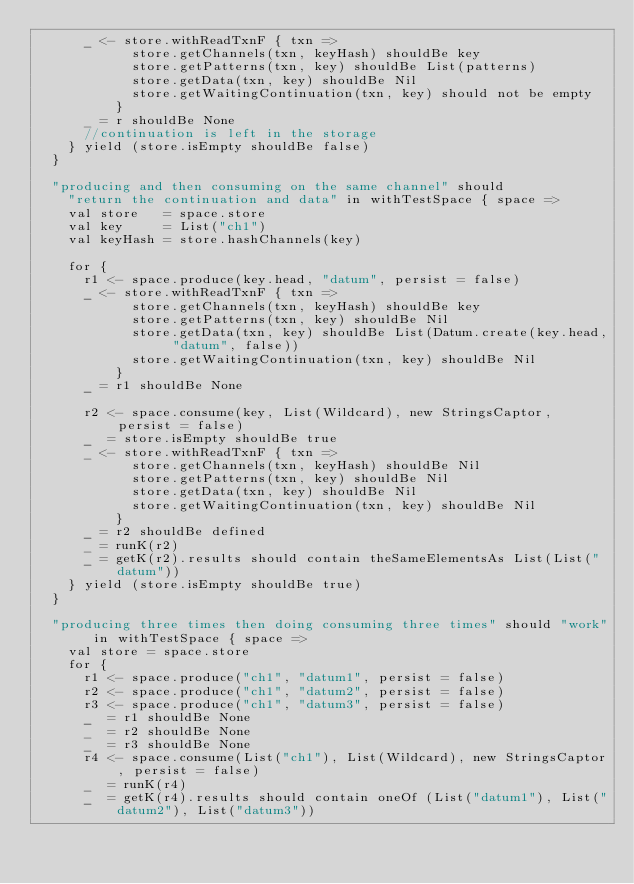<code> <loc_0><loc_0><loc_500><loc_500><_Scala_>      _ <- store.withReadTxnF { txn =>
            store.getChannels(txn, keyHash) shouldBe key
            store.getPatterns(txn, key) shouldBe List(patterns)
            store.getData(txn, key) shouldBe Nil
            store.getWaitingContinuation(txn, key) should not be empty
          }
      _ = r shouldBe None
      //continuation is left in the storage
    } yield (store.isEmpty shouldBe false)
  }

  "producing and then consuming on the same channel" should
    "return the continuation and data" in withTestSpace { space =>
    val store   = space.store
    val key     = List("ch1")
    val keyHash = store.hashChannels(key)

    for {
      r1 <- space.produce(key.head, "datum", persist = false)
      _ <- store.withReadTxnF { txn =>
            store.getChannels(txn, keyHash) shouldBe key
            store.getPatterns(txn, key) shouldBe Nil
            store.getData(txn, key) shouldBe List(Datum.create(key.head, "datum", false))
            store.getWaitingContinuation(txn, key) shouldBe Nil
          }
      _ = r1 shouldBe None

      r2 <- space.consume(key, List(Wildcard), new StringsCaptor, persist = false)
      _  = store.isEmpty shouldBe true
      _ <- store.withReadTxnF { txn =>
            store.getChannels(txn, keyHash) shouldBe Nil
            store.getPatterns(txn, key) shouldBe Nil
            store.getData(txn, key) shouldBe Nil
            store.getWaitingContinuation(txn, key) shouldBe Nil
          }
      _ = r2 shouldBe defined
      _ = runK(r2)
      _ = getK(r2).results should contain theSameElementsAs List(List("datum"))
    } yield (store.isEmpty shouldBe true)
  }

  "producing three times then doing consuming three times" should "work" in withTestSpace { space =>
    val store = space.store
    for {
      r1 <- space.produce("ch1", "datum1", persist = false)
      r2 <- space.produce("ch1", "datum2", persist = false)
      r3 <- space.produce("ch1", "datum3", persist = false)
      _  = r1 shouldBe None
      _  = r2 shouldBe None
      _  = r3 shouldBe None
      r4 <- space.consume(List("ch1"), List(Wildcard), new StringsCaptor, persist = false)
      _  = runK(r4)
      _  = getK(r4).results should contain oneOf (List("datum1"), List("datum2"), List("datum3"))</code> 